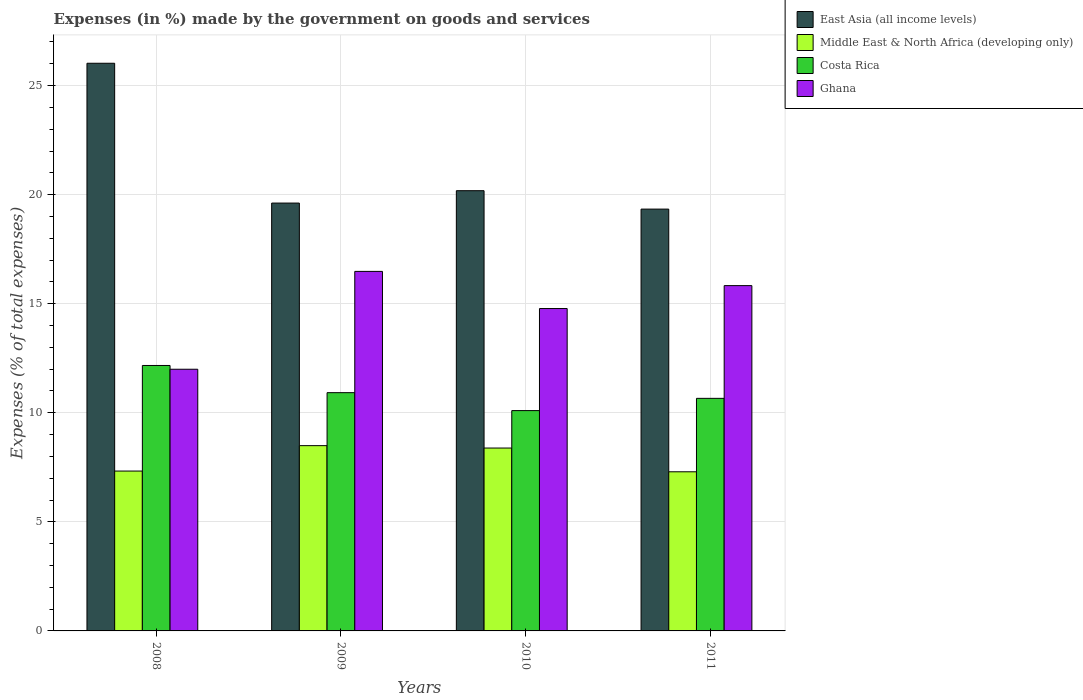How many different coloured bars are there?
Offer a terse response. 4. How many groups of bars are there?
Provide a short and direct response. 4. Are the number of bars per tick equal to the number of legend labels?
Make the answer very short. Yes. How many bars are there on the 3rd tick from the right?
Your answer should be compact. 4. What is the label of the 4th group of bars from the left?
Provide a short and direct response. 2011. In how many cases, is the number of bars for a given year not equal to the number of legend labels?
Give a very brief answer. 0. What is the percentage of expenses made by the government on goods and services in East Asia (all income levels) in 2008?
Your answer should be very brief. 26.02. Across all years, what is the maximum percentage of expenses made by the government on goods and services in Ghana?
Give a very brief answer. 16.48. Across all years, what is the minimum percentage of expenses made by the government on goods and services in Costa Rica?
Provide a short and direct response. 10.1. In which year was the percentage of expenses made by the government on goods and services in Costa Rica minimum?
Ensure brevity in your answer.  2010. What is the total percentage of expenses made by the government on goods and services in Ghana in the graph?
Ensure brevity in your answer.  59.09. What is the difference between the percentage of expenses made by the government on goods and services in East Asia (all income levels) in 2008 and that in 2011?
Your answer should be very brief. 6.69. What is the difference between the percentage of expenses made by the government on goods and services in Costa Rica in 2011 and the percentage of expenses made by the government on goods and services in Ghana in 2010?
Offer a very short reply. -4.12. What is the average percentage of expenses made by the government on goods and services in Ghana per year?
Give a very brief answer. 14.77. In the year 2010, what is the difference between the percentage of expenses made by the government on goods and services in East Asia (all income levels) and percentage of expenses made by the government on goods and services in Ghana?
Make the answer very short. 5.4. What is the ratio of the percentage of expenses made by the government on goods and services in East Asia (all income levels) in 2009 to that in 2010?
Your answer should be compact. 0.97. Is the difference between the percentage of expenses made by the government on goods and services in East Asia (all income levels) in 2008 and 2009 greater than the difference between the percentage of expenses made by the government on goods and services in Ghana in 2008 and 2009?
Make the answer very short. Yes. What is the difference between the highest and the second highest percentage of expenses made by the government on goods and services in Middle East & North Africa (developing only)?
Provide a short and direct response. 0.11. What is the difference between the highest and the lowest percentage of expenses made by the government on goods and services in Middle East & North Africa (developing only)?
Your answer should be very brief. 1.2. In how many years, is the percentage of expenses made by the government on goods and services in Costa Rica greater than the average percentage of expenses made by the government on goods and services in Costa Rica taken over all years?
Make the answer very short. 1. Is the sum of the percentage of expenses made by the government on goods and services in Ghana in 2008 and 2010 greater than the maximum percentage of expenses made by the government on goods and services in Costa Rica across all years?
Keep it short and to the point. Yes. Is it the case that in every year, the sum of the percentage of expenses made by the government on goods and services in East Asia (all income levels) and percentage of expenses made by the government on goods and services in Costa Rica is greater than the sum of percentage of expenses made by the government on goods and services in Ghana and percentage of expenses made by the government on goods and services in Middle East & North Africa (developing only)?
Provide a short and direct response. Yes. What does the 3rd bar from the left in 2010 represents?
Your response must be concise. Costa Rica. What does the 1st bar from the right in 2008 represents?
Offer a very short reply. Ghana. How many bars are there?
Provide a short and direct response. 16. Does the graph contain grids?
Keep it short and to the point. Yes. Where does the legend appear in the graph?
Keep it short and to the point. Top right. How many legend labels are there?
Provide a succinct answer. 4. What is the title of the graph?
Ensure brevity in your answer.  Expenses (in %) made by the government on goods and services. Does "Niger" appear as one of the legend labels in the graph?
Your response must be concise. No. What is the label or title of the X-axis?
Ensure brevity in your answer.  Years. What is the label or title of the Y-axis?
Your response must be concise. Expenses (% of total expenses). What is the Expenses (% of total expenses) of East Asia (all income levels) in 2008?
Offer a terse response. 26.02. What is the Expenses (% of total expenses) of Middle East & North Africa (developing only) in 2008?
Make the answer very short. 7.33. What is the Expenses (% of total expenses) of Costa Rica in 2008?
Offer a very short reply. 12.17. What is the Expenses (% of total expenses) of Ghana in 2008?
Your response must be concise. 12. What is the Expenses (% of total expenses) of East Asia (all income levels) in 2009?
Give a very brief answer. 19.62. What is the Expenses (% of total expenses) in Middle East & North Africa (developing only) in 2009?
Offer a terse response. 8.49. What is the Expenses (% of total expenses) in Costa Rica in 2009?
Keep it short and to the point. 10.92. What is the Expenses (% of total expenses) in Ghana in 2009?
Provide a succinct answer. 16.48. What is the Expenses (% of total expenses) of East Asia (all income levels) in 2010?
Give a very brief answer. 20.18. What is the Expenses (% of total expenses) of Middle East & North Africa (developing only) in 2010?
Provide a short and direct response. 8.38. What is the Expenses (% of total expenses) of Costa Rica in 2010?
Ensure brevity in your answer.  10.1. What is the Expenses (% of total expenses) in Ghana in 2010?
Your answer should be compact. 14.78. What is the Expenses (% of total expenses) of East Asia (all income levels) in 2011?
Give a very brief answer. 19.34. What is the Expenses (% of total expenses) in Middle East & North Africa (developing only) in 2011?
Offer a very short reply. 7.3. What is the Expenses (% of total expenses) in Costa Rica in 2011?
Your answer should be very brief. 10.66. What is the Expenses (% of total expenses) in Ghana in 2011?
Your answer should be very brief. 15.83. Across all years, what is the maximum Expenses (% of total expenses) in East Asia (all income levels)?
Provide a short and direct response. 26.02. Across all years, what is the maximum Expenses (% of total expenses) in Middle East & North Africa (developing only)?
Make the answer very short. 8.49. Across all years, what is the maximum Expenses (% of total expenses) in Costa Rica?
Keep it short and to the point. 12.17. Across all years, what is the maximum Expenses (% of total expenses) of Ghana?
Your answer should be very brief. 16.48. Across all years, what is the minimum Expenses (% of total expenses) in East Asia (all income levels)?
Keep it short and to the point. 19.34. Across all years, what is the minimum Expenses (% of total expenses) in Middle East & North Africa (developing only)?
Provide a short and direct response. 7.3. Across all years, what is the minimum Expenses (% of total expenses) of Costa Rica?
Keep it short and to the point. 10.1. Across all years, what is the minimum Expenses (% of total expenses) of Ghana?
Make the answer very short. 12. What is the total Expenses (% of total expenses) in East Asia (all income levels) in the graph?
Offer a very short reply. 85.16. What is the total Expenses (% of total expenses) of Middle East & North Africa (developing only) in the graph?
Make the answer very short. 31.5. What is the total Expenses (% of total expenses) of Costa Rica in the graph?
Your response must be concise. 43.86. What is the total Expenses (% of total expenses) of Ghana in the graph?
Ensure brevity in your answer.  59.09. What is the difference between the Expenses (% of total expenses) in East Asia (all income levels) in 2008 and that in 2009?
Offer a very short reply. 6.41. What is the difference between the Expenses (% of total expenses) of Middle East & North Africa (developing only) in 2008 and that in 2009?
Your answer should be very brief. -1.17. What is the difference between the Expenses (% of total expenses) in Costa Rica in 2008 and that in 2009?
Give a very brief answer. 1.25. What is the difference between the Expenses (% of total expenses) in Ghana in 2008 and that in 2009?
Keep it short and to the point. -4.49. What is the difference between the Expenses (% of total expenses) of East Asia (all income levels) in 2008 and that in 2010?
Your answer should be compact. 5.84. What is the difference between the Expenses (% of total expenses) in Middle East & North Africa (developing only) in 2008 and that in 2010?
Provide a succinct answer. -1.06. What is the difference between the Expenses (% of total expenses) in Costa Rica in 2008 and that in 2010?
Keep it short and to the point. 2.07. What is the difference between the Expenses (% of total expenses) of Ghana in 2008 and that in 2010?
Provide a succinct answer. -2.78. What is the difference between the Expenses (% of total expenses) in East Asia (all income levels) in 2008 and that in 2011?
Give a very brief answer. 6.69. What is the difference between the Expenses (% of total expenses) in Middle East & North Africa (developing only) in 2008 and that in 2011?
Provide a succinct answer. 0.03. What is the difference between the Expenses (% of total expenses) in Costa Rica in 2008 and that in 2011?
Ensure brevity in your answer.  1.51. What is the difference between the Expenses (% of total expenses) in Ghana in 2008 and that in 2011?
Offer a terse response. -3.83. What is the difference between the Expenses (% of total expenses) of East Asia (all income levels) in 2009 and that in 2010?
Ensure brevity in your answer.  -0.57. What is the difference between the Expenses (% of total expenses) in Middle East & North Africa (developing only) in 2009 and that in 2010?
Offer a very short reply. 0.11. What is the difference between the Expenses (% of total expenses) in Costa Rica in 2009 and that in 2010?
Provide a short and direct response. 0.82. What is the difference between the Expenses (% of total expenses) in Ghana in 2009 and that in 2010?
Make the answer very short. 1.7. What is the difference between the Expenses (% of total expenses) in East Asia (all income levels) in 2009 and that in 2011?
Give a very brief answer. 0.28. What is the difference between the Expenses (% of total expenses) of Middle East & North Africa (developing only) in 2009 and that in 2011?
Give a very brief answer. 1.2. What is the difference between the Expenses (% of total expenses) of Costa Rica in 2009 and that in 2011?
Provide a short and direct response. 0.26. What is the difference between the Expenses (% of total expenses) in Ghana in 2009 and that in 2011?
Provide a succinct answer. 0.65. What is the difference between the Expenses (% of total expenses) in East Asia (all income levels) in 2010 and that in 2011?
Offer a very short reply. 0.84. What is the difference between the Expenses (% of total expenses) in Middle East & North Africa (developing only) in 2010 and that in 2011?
Keep it short and to the point. 1.09. What is the difference between the Expenses (% of total expenses) in Costa Rica in 2010 and that in 2011?
Your answer should be very brief. -0.56. What is the difference between the Expenses (% of total expenses) in Ghana in 2010 and that in 2011?
Offer a very short reply. -1.05. What is the difference between the Expenses (% of total expenses) in East Asia (all income levels) in 2008 and the Expenses (% of total expenses) in Middle East & North Africa (developing only) in 2009?
Provide a short and direct response. 17.53. What is the difference between the Expenses (% of total expenses) in East Asia (all income levels) in 2008 and the Expenses (% of total expenses) in Costa Rica in 2009?
Provide a succinct answer. 15.1. What is the difference between the Expenses (% of total expenses) in East Asia (all income levels) in 2008 and the Expenses (% of total expenses) in Ghana in 2009?
Offer a very short reply. 9.54. What is the difference between the Expenses (% of total expenses) in Middle East & North Africa (developing only) in 2008 and the Expenses (% of total expenses) in Costa Rica in 2009?
Your answer should be very brief. -3.59. What is the difference between the Expenses (% of total expenses) of Middle East & North Africa (developing only) in 2008 and the Expenses (% of total expenses) of Ghana in 2009?
Ensure brevity in your answer.  -9.15. What is the difference between the Expenses (% of total expenses) in Costa Rica in 2008 and the Expenses (% of total expenses) in Ghana in 2009?
Offer a terse response. -4.31. What is the difference between the Expenses (% of total expenses) of East Asia (all income levels) in 2008 and the Expenses (% of total expenses) of Middle East & North Africa (developing only) in 2010?
Your answer should be compact. 17.64. What is the difference between the Expenses (% of total expenses) in East Asia (all income levels) in 2008 and the Expenses (% of total expenses) in Costa Rica in 2010?
Offer a terse response. 15.92. What is the difference between the Expenses (% of total expenses) in East Asia (all income levels) in 2008 and the Expenses (% of total expenses) in Ghana in 2010?
Give a very brief answer. 11.24. What is the difference between the Expenses (% of total expenses) of Middle East & North Africa (developing only) in 2008 and the Expenses (% of total expenses) of Costa Rica in 2010?
Offer a very short reply. -2.77. What is the difference between the Expenses (% of total expenses) in Middle East & North Africa (developing only) in 2008 and the Expenses (% of total expenses) in Ghana in 2010?
Make the answer very short. -7.45. What is the difference between the Expenses (% of total expenses) in Costa Rica in 2008 and the Expenses (% of total expenses) in Ghana in 2010?
Offer a very short reply. -2.61. What is the difference between the Expenses (% of total expenses) in East Asia (all income levels) in 2008 and the Expenses (% of total expenses) in Middle East & North Africa (developing only) in 2011?
Your answer should be compact. 18.73. What is the difference between the Expenses (% of total expenses) of East Asia (all income levels) in 2008 and the Expenses (% of total expenses) of Costa Rica in 2011?
Give a very brief answer. 15.36. What is the difference between the Expenses (% of total expenses) in East Asia (all income levels) in 2008 and the Expenses (% of total expenses) in Ghana in 2011?
Offer a terse response. 10.19. What is the difference between the Expenses (% of total expenses) of Middle East & North Africa (developing only) in 2008 and the Expenses (% of total expenses) of Costa Rica in 2011?
Ensure brevity in your answer.  -3.33. What is the difference between the Expenses (% of total expenses) in Middle East & North Africa (developing only) in 2008 and the Expenses (% of total expenses) in Ghana in 2011?
Make the answer very short. -8.5. What is the difference between the Expenses (% of total expenses) of Costa Rica in 2008 and the Expenses (% of total expenses) of Ghana in 2011?
Keep it short and to the point. -3.66. What is the difference between the Expenses (% of total expenses) in East Asia (all income levels) in 2009 and the Expenses (% of total expenses) in Middle East & North Africa (developing only) in 2010?
Your answer should be very brief. 11.23. What is the difference between the Expenses (% of total expenses) of East Asia (all income levels) in 2009 and the Expenses (% of total expenses) of Costa Rica in 2010?
Provide a short and direct response. 9.51. What is the difference between the Expenses (% of total expenses) in East Asia (all income levels) in 2009 and the Expenses (% of total expenses) in Ghana in 2010?
Give a very brief answer. 4.84. What is the difference between the Expenses (% of total expenses) of Middle East & North Africa (developing only) in 2009 and the Expenses (% of total expenses) of Costa Rica in 2010?
Ensure brevity in your answer.  -1.61. What is the difference between the Expenses (% of total expenses) in Middle East & North Africa (developing only) in 2009 and the Expenses (% of total expenses) in Ghana in 2010?
Provide a succinct answer. -6.29. What is the difference between the Expenses (% of total expenses) of Costa Rica in 2009 and the Expenses (% of total expenses) of Ghana in 2010?
Give a very brief answer. -3.86. What is the difference between the Expenses (% of total expenses) of East Asia (all income levels) in 2009 and the Expenses (% of total expenses) of Middle East & North Africa (developing only) in 2011?
Offer a terse response. 12.32. What is the difference between the Expenses (% of total expenses) of East Asia (all income levels) in 2009 and the Expenses (% of total expenses) of Costa Rica in 2011?
Make the answer very short. 8.95. What is the difference between the Expenses (% of total expenses) of East Asia (all income levels) in 2009 and the Expenses (% of total expenses) of Ghana in 2011?
Your response must be concise. 3.78. What is the difference between the Expenses (% of total expenses) of Middle East & North Africa (developing only) in 2009 and the Expenses (% of total expenses) of Costa Rica in 2011?
Ensure brevity in your answer.  -2.17. What is the difference between the Expenses (% of total expenses) of Middle East & North Africa (developing only) in 2009 and the Expenses (% of total expenses) of Ghana in 2011?
Give a very brief answer. -7.34. What is the difference between the Expenses (% of total expenses) of Costa Rica in 2009 and the Expenses (% of total expenses) of Ghana in 2011?
Your answer should be very brief. -4.91. What is the difference between the Expenses (% of total expenses) in East Asia (all income levels) in 2010 and the Expenses (% of total expenses) in Middle East & North Africa (developing only) in 2011?
Offer a very short reply. 12.89. What is the difference between the Expenses (% of total expenses) in East Asia (all income levels) in 2010 and the Expenses (% of total expenses) in Costa Rica in 2011?
Offer a very short reply. 9.52. What is the difference between the Expenses (% of total expenses) in East Asia (all income levels) in 2010 and the Expenses (% of total expenses) in Ghana in 2011?
Your answer should be very brief. 4.35. What is the difference between the Expenses (% of total expenses) in Middle East & North Africa (developing only) in 2010 and the Expenses (% of total expenses) in Costa Rica in 2011?
Keep it short and to the point. -2.28. What is the difference between the Expenses (% of total expenses) of Middle East & North Africa (developing only) in 2010 and the Expenses (% of total expenses) of Ghana in 2011?
Offer a terse response. -7.45. What is the difference between the Expenses (% of total expenses) in Costa Rica in 2010 and the Expenses (% of total expenses) in Ghana in 2011?
Your answer should be very brief. -5.73. What is the average Expenses (% of total expenses) of East Asia (all income levels) per year?
Make the answer very short. 21.29. What is the average Expenses (% of total expenses) in Middle East & North Africa (developing only) per year?
Give a very brief answer. 7.88. What is the average Expenses (% of total expenses) of Costa Rica per year?
Your response must be concise. 10.96. What is the average Expenses (% of total expenses) in Ghana per year?
Provide a short and direct response. 14.77. In the year 2008, what is the difference between the Expenses (% of total expenses) of East Asia (all income levels) and Expenses (% of total expenses) of Middle East & North Africa (developing only)?
Ensure brevity in your answer.  18.7. In the year 2008, what is the difference between the Expenses (% of total expenses) in East Asia (all income levels) and Expenses (% of total expenses) in Costa Rica?
Your response must be concise. 13.86. In the year 2008, what is the difference between the Expenses (% of total expenses) of East Asia (all income levels) and Expenses (% of total expenses) of Ghana?
Provide a short and direct response. 14.03. In the year 2008, what is the difference between the Expenses (% of total expenses) of Middle East & North Africa (developing only) and Expenses (% of total expenses) of Costa Rica?
Your answer should be very brief. -4.84. In the year 2008, what is the difference between the Expenses (% of total expenses) in Middle East & North Africa (developing only) and Expenses (% of total expenses) in Ghana?
Ensure brevity in your answer.  -4.67. In the year 2008, what is the difference between the Expenses (% of total expenses) of Costa Rica and Expenses (% of total expenses) of Ghana?
Your answer should be compact. 0.17. In the year 2009, what is the difference between the Expenses (% of total expenses) of East Asia (all income levels) and Expenses (% of total expenses) of Middle East & North Africa (developing only)?
Offer a terse response. 11.12. In the year 2009, what is the difference between the Expenses (% of total expenses) in East Asia (all income levels) and Expenses (% of total expenses) in Costa Rica?
Provide a short and direct response. 8.69. In the year 2009, what is the difference between the Expenses (% of total expenses) of East Asia (all income levels) and Expenses (% of total expenses) of Ghana?
Your response must be concise. 3.13. In the year 2009, what is the difference between the Expenses (% of total expenses) in Middle East & North Africa (developing only) and Expenses (% of total expenses) in Costa Rica?
Give a very brief answer. -2.43. In the year 2009, what is the difference between the Expenses (% of total expenses) of Middle East & North Africa (developing only) and Expenses (% of total expenses) of Ghana?
Your answer should be compact. -7.99. In the year 2009, what is the difference between the Expenses (% of total expenses) of Costa Rica and Expenses (% of total expenses) of Ghana?
Your response must be concise. -5.56. In the year 2010, what is the difference between the Expenses (% of total expenses) of East Asia (all income levels) and Expenses (% of total expenses) of Middle East & North Africa (developing only)?
Offer a very short reply. 11.8. In the year 2010, what is the difference between the Expenses (% of total expenses) of East Asia (all income levels) and Expenses (% of total expenses) of Costa Rica?
Provide a succinct answer. 10.08. In the year 2010, what is the difference between the Expenses (% of total expenses) of East Asia (all income levels) and Expenses (% of total expenses) of Ghana?
Your response must be concise. 5.4. In the year 2010, what is the difference between the Expenses (% of total expenses) in Middle East & North Africa (developing only) and Expenses (% of total expenses) in Costa Rica?
Offer a very short reply. -1.72. In the year 2010, what is the difference between the Expenses (% of total expenses) of Middle East & North Africa (developing only) and Expenses (% of total expenses) of Ghana?
Your answer should be compact. -6.4. In the year 2010, what is the difference between the Expenses (% of total expenses) of Costa Rica and Expenses (% of total expenses) of Ghana?
Your response must be concise. -4.68. In the year 2011, what is the difference between the Expenses (% of total expenses) in East Asia (all income levels) and Expenses (% of total expenses) in Middle East & North Africa (developing only)?
Your answer should be compact. 12.04. In the year 2011, what is the difference between the Expenses (% of total expenses) of East Asia (all income levels) and Expenses (% of total expenses) of Costa Rica?
Provide a succinct answer. 8.68. In the year 2011, what is the difference between the Expenses (% of total expenses) of East Asia (all income levels) and Expenses (% of total expenses) of Ghana?
Ensure brevity in your answer.  3.51. In the year 2011, what is the difference between the Expenses (% of total expenses) in Middle East & North Africa (developing only) and Expenses (% of total expenses) in Costa Rica?
Your answer should be very brief. -3.37. In the year 2011, what is the difference between the Expenses (% of total expenses) in Middle East & North Africa (developing only) and Expenses (% of total expenses) in Ghana?
Your response must be concise. -8.53. In the year 2011, what is the difference between the Expenses (% of total expenses) of Costa Rica and Expenses (% of total expenses) of Ghana?
Offer a terse response. -5.17. What is the ratio of the Expenses (% of total expenses) of East Asia (all income levels) in 2008 to that in 2009?
Provide a short and direct response. 1.33. What is the ratio of the Expenses (% of total expenses) in Middle East & North Africa (developing only) in 2008 to that in 2009?
Make the answer very short. 0.86. What is the ratio of the Expenses (% of total expenses) of Costa Rica in 2008 to that in 2009?
Your response must be concise. 1.11. What is the ratio of the Expenses (% of total expenses) of Ghana in 2008 to that in 2009?
Provide a short and direct response. 0.73. What is the ratio of the Expenses (% of total expenses) of East Asia (all income levels) in 2008 to that in 2010?
Offer a terse response. 1.29. What is the ratio of the Expenses (% of total expenses) of Middle East & North Africa (developing only) in 2008 to that in 2010?
Make the answer very short. 0.87. What is the ratio of the Expenses (% of total expenses) in Costa Rica in 2008 to that in 2010?
Offer a terse response. 1.2. What is the ratio of the Expenses (% of total expenses) in Ghana in 2008 to that in 2010?
Make the answer very short. 0.81. What is the ratio of the Expenses (% of total expenses) of East Asia (all income levels) in 2008 to that in 2011?
Ensure brevity in your answer.  1.35. What is the ratio of the Expenses (% of total expenses) of Costa Rica in 2008 to that in 2011?
Your answer should be very brief. 1.14. What is the ratio of the Expenses (% of total expenses) of Ghana in 2008 to that in 2011?
Provide a succinct answer. 0.76. What is the ratio of the Expenses (% of total expenses) of East Asia (all income levels) in 2009 to that in 2010?
Your answer should be compact. 0.97. What is the ratio of the Expenses (% of total expenses) in Middle East & North Africa (developing only) in 2009 to that in 2010?
Ensure brevity in your answer.  1.01. What is the ratio of the Expenses (% of total expenses) of Costa Rica in 2009 to that in 2010?
Provide a short and direct response. 1.08. What is the ratio of the Expenses (% of total expenses) in Ghana in 2009 to that in 2010?
Your response must be concise. 1.12. What is the ratio of the Expenses (% of total expenses) in East Asia (all income levels) in 2009 to that in 2011?
Your answer should be very brief. 1.01. What is the ratio of the Expenses (% of total expenses) in Middle East & North Africa (developing only) in 2009 to that in 2011?
Your answer should be compact. 1.16. What is the ratio of the Expenses (% of total expenses) of Costa Rica in 2009 to that in 2011?
Offer a very short reply. 1.02. What is the ratio of the Expenses (% of total expenses) of Ghana in 2009 to that in 2011?
Your answer should be compact. 1.04. What is the ratio of the Expenses (% of total expenses) of East Asia (all income levels) in 2010 to that in 2011?
Provide a short and direct response. 1.04. What is the ratio of the Expenses (% of total expenses) of Middle East & North Africa (developing only) in 2010 to that in 2011?
Make the answer very short. 1.15. What is the ratio of the Expenses (% of total expenses) in Costa Rica in 2010 to that in 2011?
Your response must be concise. 0.95. What is the ratio of the Expenses (% of total expenses) in Ghana in 2010 to that in 2011?
Your answer should be very brief. 0.93. What is the difference between the highest and the second highest Expenses (% of total expenses) of East Asia (all income levels)?
Make the answer very short. 5.84. What is the difference between the highest and the second highest Expenses (% of total expenses) of Middle East & North Africa (developing only)?
Keep it short and to the point. 0.11. What is the difference between the highest and the second highest Expenses (% of total expenses) in Costa Rica?
Make the answer very short. 1.25. What is the difference between the highest and the second highest Expenses (% of total expenses) of Ghana?
Make the answer very short. 0.65. What is the difference between the highest and the lowest Expenses (% of total expenses) of East Asia (all income levels)?
Offer a terse response. 6.69. What is the difference between the highest and the lowest Expenses (% of total expenses) in Middle East & North Africa (developing only)?
Keep it short and to the point. 1.2. What is the difference between the highest and the lowest Expenses (% of total expenses) in Costa Rica?
Give a very brief answer. 2.07. What is the difference between the highest and the lowest Expenses (% of total expenses) in Ghana?
Make the answer very short. 4.49. 